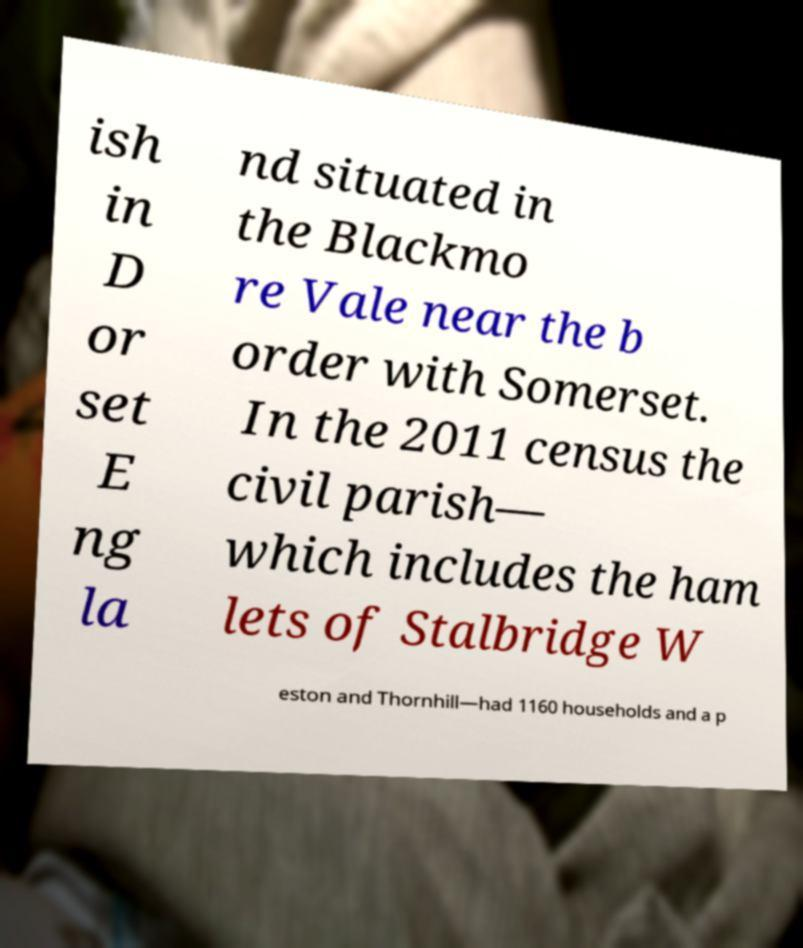Could you assist in decoding the text presented in this image and type it out clearly? ish in D or set E ng la nd situated in the Blackmo re Vale near the b order with Somerset. In the 2011 census the civil parish— which includes the ham lets of Stalbridge W eston and Thornhill—had 1160 households and a p 